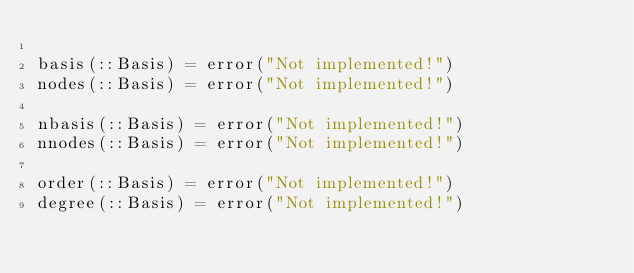Convert code to text. <code><loc_0><loc_0><loc_500><loc_500><_Julia_>
basis(::Basis) = error("Not implemented!")
nodes(::Basis) = error("Not implemented!")

nbasis(::Basis) = error("Not implemented!")
nnodes(::Basis) = error("Not implemented!")

order(::Basis) = error("Not implemented!")
degree(::Basis) = error("Not implemented!")
</code> 